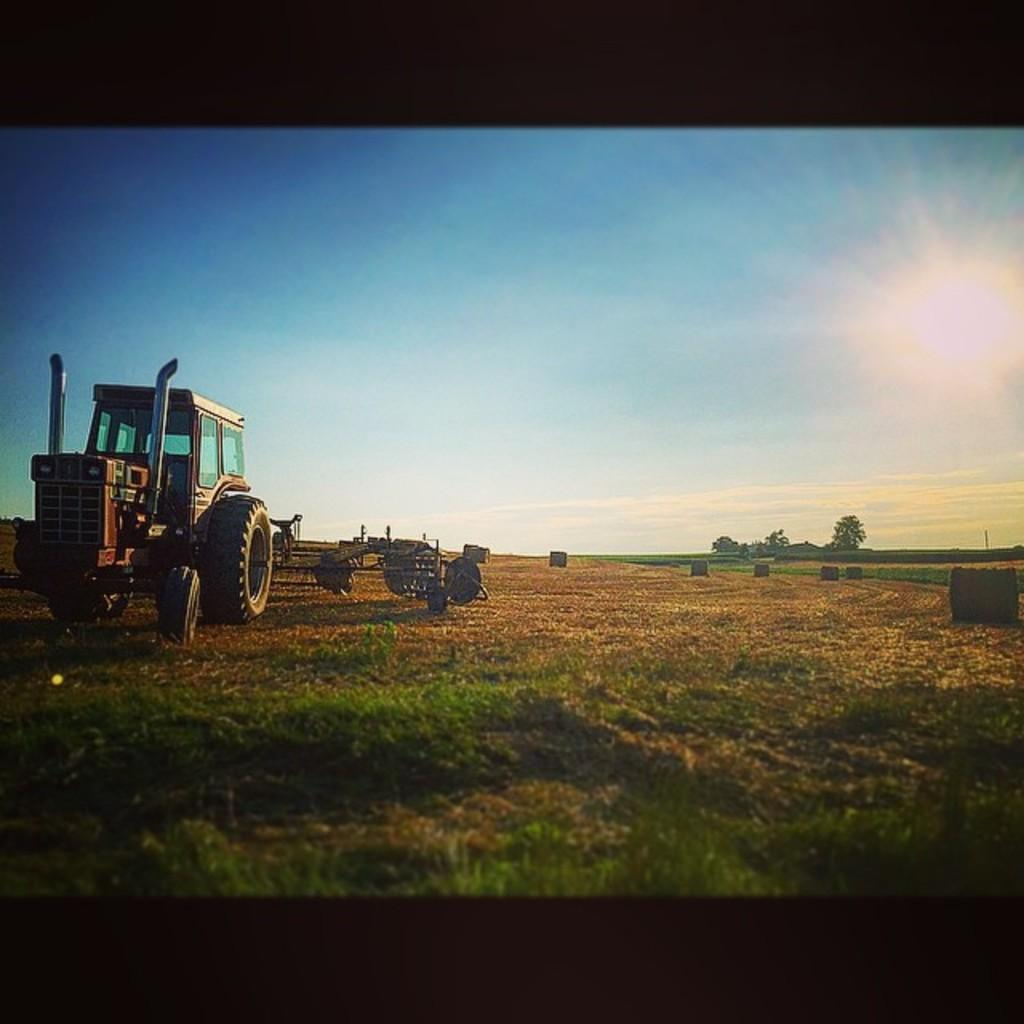What type of vehicle is on the left side of the image? There is a vehicle on the left side of the image, but the specific type is not mentioned in the facts. What is at the bottom of the image? There is grass at the bottom of the image. What can be seen on the right side of the image? There are trees on the right side of the image. What is visible at the top of the image? The sky is visible at the top of the image. What type of mist can be seen surrounding the vehicle in the image? There is no mention of mist in the image; it only states that there is a vehicle on the left side of the image. What type of coach is present in the image? There is no coach present in the image. 